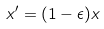Convert formula to latex. <formula><loc_0><loc_0><loc_500><loc_500>x ^ { \prime } = ( 1 - \epsilon ) x</formula> 